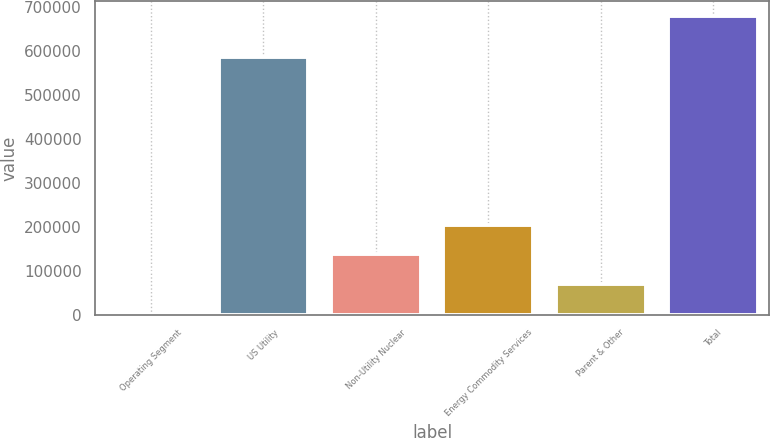Convert chart to OTSL. <chart><loc_0><loc_0><loc_500><loc_500><bar_chart><fcel>Operating Segment<fcel>US Utility<fcel>Non-Utility Nuclear<fcel>Energy Commodity Services<fcel>Parent & Other<fcel>Total<nl><fcel>2000<fcel>586642<fcel>137459<fcel>205188<fcel>69729.4<fcel>679294<nl></chart> 